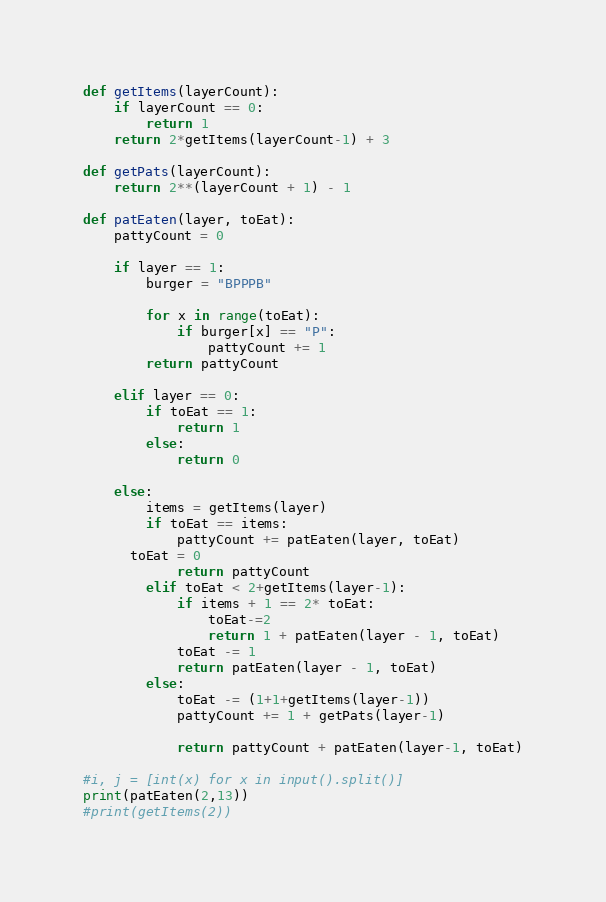<code> <loc_0><loc_0><loc_500><loc_500><_Python_>def getItems(layerCount):
	if layerCount == 0:
		return 1
	return 2*getItems(layerCount-1) + 3

def getPats(layerCount):
	return 2**(layerCount + 1) - 1

def patEaten(layer, toEat):
	pattyCount = 0

	if layer == 1:
		burger = "BPPPB"

		for x in range(toEat):
			if burger[x] == "P":
				pattyCount += 1
		return pattyCount
		
	elif layer == 0:
		if toEat == 1:
			return 1
		else:
			return 0
	
	else:
		items = getItems(layer)
		if toEat == items:
			pattyCount += patEaten(layer, toEat)
      toEat = 0
			return pattyCount
		elif toEat < 2+getItems(layer-1):
			if items + 1 == 2* toEat:
				toEat-=2
				return 1 + patEaten(layer - 1, toEat)
			toEat -= 1
			return patEaten(layer - 1, toEat)
		else:
			toEat -= (1+1+getItems(layer-1))
			pattyCount += 1 + getPats(layer-1)
			
			return pattyCount + patEaten(layer-1, toEat)

#i, j = [int(x) for x in input().split()]
print(patEaten(2,13))
#print(getItems(2))</code> 